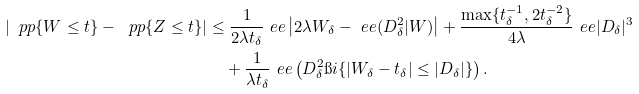<formula> <loc_0><loc_0><loc_500><loc_500>| \ p p \{ W \leq t \} - \ p p \{ Z \leq t \} | & \leq \frac { 1 } { 2 \lambda t _ { \delta } } \ e e \left | 2 \lambda W _ { \delta } - \ e e ( D _ { \delta } ^ { 2 } | W ) \right | + \frac { \max \{ t _ { \delta } ^ { - 1 } , 2 t _ { \delta } ^ { - 2 } \} } { 4 \lambda } \ e e | D _ { \delta } | ^ { 3 } \\ & \quad + \frac { 1 } { \lambda t _ { \delta } } \ e e \left ( D _ { \delta } ^ { 2 } \i i \{ | W _ { \delta } - t _ { \delta } | \leq | D _ { \delta } | \} \right ) .</formula> 